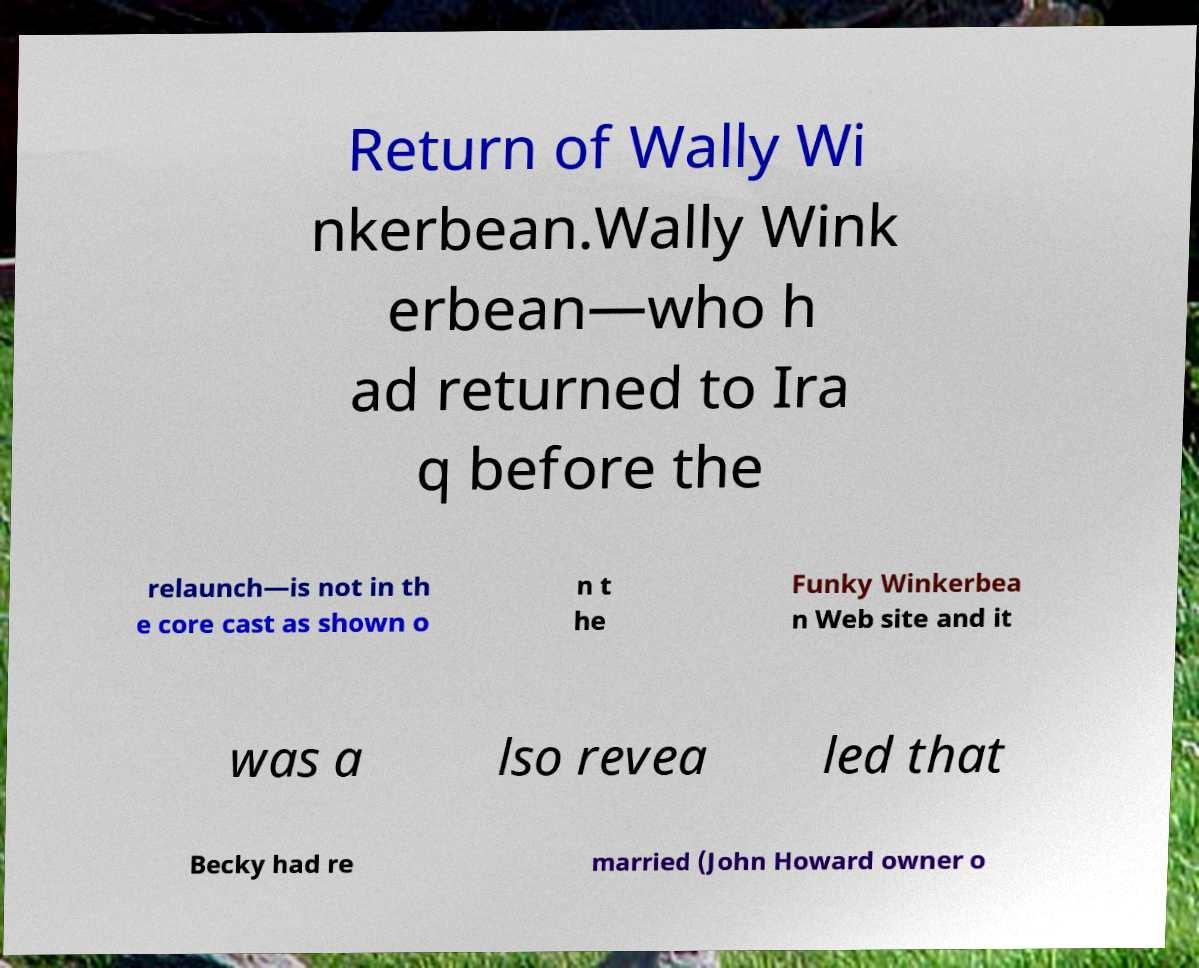There's text embedded in this image that I need extracted. Can you transcribe it verbatim? Return of Wally Wi nkerbean.Wally Wink erbean—who h ad returned to Ira q before the relaunch—is not in th e core cast as shown o n t he Funky Winkerbea n Web site and it was a lso revea led that Becky had re married (John Howard owner o 